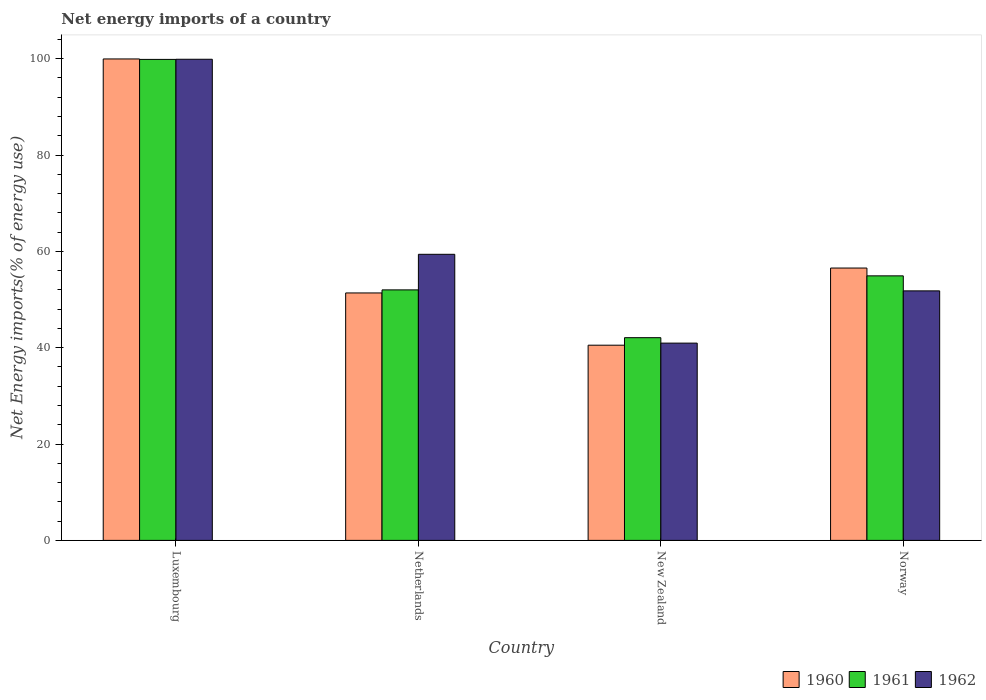Are the number of bars per tick equal to the number of legend labels?
Make the answer very short. Yes. Are the number of bars on each tick of the X-axis equal?
Ensure brevity in your answer.  Yes. How many bars are there on the 3rd tick from the right?
Offer a very short reply. 3. What is the label of the 3rd group of bars from the left?
Give a very brief answer. New Zealand. What is the net energy imports in 1960 in Luxembourg?
Your response must be concise. 99.95. Across all countries, what is the maximum net energy imports in 1962?
Offer a terse response. 99.88. Across all countries, what is the minimum net energy imports in 1962?
Offer a very short reply. 40.95. In which country was the net energy imports in 1961 maximum?
Keep it short and to the point. Luxembourg. In which country was the net energy imports in 1961 minimum?
Offer a terse response. New Zealand. What is the total net energy imports in 1962 in the graph?
Give a very brief answer. 252.03. What is the difference between the net energy imports in 1960 in Luxembourg and that in Norway?
Keep it short and to the point. 43.41. What is the difference between the net energy imports in 1962 in New Zealand and the net energy imports in 1960 in Netherlands?
Your answer should be very brief. -10.42. What is the average net energy imports in 1961 per country?
Your answer should be compact. 62.21. What is the difference between the net energy imports of/in 1961 and net energy imports of/in 1960 in Norway?
Offer a very short reply. -1.62. What is the ratio of the net energy imports in 1961 in Luxembourg to that in Norway?
Provide a short and direct response. 1.82. Is the difference between the net energy imports in 1961 in Netherlands and Norway greater than the difference between the net energy imports in 1960 in Netherlands and Norway?
Your answer should be compact. Yes. What is the difference between the highest and the second highest net energy imports in 1962?
Provide a succinct answer. -40.49. What is the difference between the highest and the lowest net energy imports in 1960?
Your response must be concise. 59.43. In how many countries, is the net energy imports in 1960 greater than the average net energy imports in 1960 taken over all countries?
Your answer should be very brief. 1. What does the 2nd bar from the left in Luxembourg represents?
Your response must be concise. 1961. Is it the case that in every country, the sum of the net energy imports in 1962 and net energy imports in 1961 is greater than the net energy imports in 1960?
Offer a terse response. Yes. How many bars are there?
Give a very brief answer. 12. How many countries are there in the graph?
Your answer should be very brief. 4. What is the difference between two consecutive major ticks on the Y-axis?
Ensure brevity in your answer.  20. Where does the legend appear in the graph?
Provide a succinct answer. Bottom right. How many legend labels are there?
Ensure brevity in your answer.  3. What is the title of the graph?
Give a very brief answer. Net energy imports of a country. What is the label or title of the X-axis?
Ensure brevity in your answer.  Country. What is the label or title of the Y-axis?
Provide a short and direct response. Net Energy imports(% of energy use). What is the Net Energy imports(% of energy use) in 1960 in Luxembourg?
Your response must be concise. 99.95. What is the Net Energy imports(% of energy use) in 1961 in Luxembourg?
Make the answer very short. 99.85. What is the Net Energy imports(% of energy use) of 1962 in Luxembourg?
Provide a short and direct response. 99.88. What is the Net Energy imports(% of energy use) of 1960 in Netherlands?
Make the answer very short. 51.37. What is the Net Energy imports(% of energy use) in 1961 in Netherlands?
Provide a short and direct response. 52. What is the Net Energy imports(% of energy use) of 1962 in Netherlands?
Provide a succinct answer. 59.39. What is the Net Energy imports(% of energy use) of 1960 in New Zealand?
Your response must be concise. 40.52. What is the Net Energy imports(% of energy use) in 1961 in New Zealand?
Offer a terse response. 42.08. What is the Net Energy imports(% of energy use) of 1962 in New Zealand?
Your answer should be very brief. 40.95. What is the Net Energy imports(% of energy use) of 1960 in Norway?
Your answer should be compact. 56.54. What is the Net Energy imports(% of energy use) in 1961 in Norway?
Ensure brevity in your answer.  54.92. What is the Net Energy imports(% of energy use) of 1962 in Norway?
Ensure brevity in your answer.  51.8. Across all countries, what is the maximum Net Energy imports(% of energy use) of 1960?
Offer a very short reply. 99.95. Across all countries, what is the maximum Net Energy imports(% of energy use) in 1961?
Offer a very short reply. 99.85. Across all countries, what is the maximum Net Energy imports(% of energy use) of 1962?
Your answer should be very brief. 99.88. Across all countries, what is the minimum Net Energy imports(% of energy use) in 1960?
Provide a short and direct response. 40.52. Across all countries, what is the minimum Net Energy imports(% of energy use) in 1961?
Keep it short and to the point. 42.08. Across all countries, what is the minimum Net Energy imports(% of energy use) in 1962?
Make the answer very short. 40.95. What is the total Net Energy imports(% of energy use) of 1960 in the graph?
Provide a short and direct response. 248.38. What is the total Net Energy imports(% of energy use) in 1961 in the graph?
Offer a very short reply. 248.86. What is the total Net Energy imports(% of energy use) in 1962 in the graph?
Ensure brevity in your answer.  252.03. What is the difference between the Net Energy imports(% of energy use) of 1960 in Luxembourg and that in Netherlands?
Your answer should be very brief. 48.58. What is the difference between the Net Energy imports(% of energy use) of 1961 in Luxembourg and that in Netherlands?
Ensure brevity in your answer.  47.85. What is the difference between the Net Energy imports(% of energy use) in 1962 in Luxembourg and that in Netherlands?
Provide a succinct answer. 40.49. What is the difference between the Net Energy imports(% of energy use) of 1960 in Luxembourg and that in New Zealand?
Make the answer very short. 59.43. What is the difference between the Net Energy imports(% of energy use) in 1961 in Luxembourg and that in New Zealand?
Make the answer very short. 57.77. What is the difference between the Net Energy imports(% of energy use) in 1962 in Luxembourg and that in New Zealand?
Your answer should be compact. 58.93. What is the difference between the Net Energy imports(% of energy use) of 1960 in Luxembourg and that in Norway?
Give a very brief answer. 43.41. What is the difference between the Net Energy imports(% of energy use) of 1961 in Luxembourg and that in Norway?
Ensure brevity in your answer.  44.94. What is the difference between the Net Energy imports(% of energy use) of 1962 in Luxembourg and that in Norway?
Make the answer very short. 48.08. What is the difference between the Net Energy imports(% of energy use) in 1960 in Netherlands and that in New Zealand?
Your answer should be compact. 10.85. What is the difference between the Net Energy imports(% of energy use) in 1961 in Netherlands and that in New Zealand?
Keep it short and to the point. 9.92. What is the difference between the Net Energy imports(% of energy use) in 1962 in Netherlands and that in New Zealand?
Your response must be concise. 18.44. What is the difference between the Net Energy imports(% of energy use) of 1960 in Netherlands and that in Norway?
Keep it short and to the point. -5.17. What is the difference between the Net Energy imports(% of energy use) of 1961 in Netherlands and that in Norway?
Your answer should be very brief. -2.91. What is the difference between the Net Energy imports(% of energy use) of 1962 in Netherlands and that in Norway?
Make the answer very short. 7.59. What is the difference between the Net Energy imports(% of energy use) of 1960 in New Zealand and that in Norway?
Your answer should be compact. -16.02. What is the difference between the Net Energy imports(% of energy use) of 1961 in New Zealand and that in Norway?
Your response must be concise. -12.83. What is the difference between the Net Energy imports(% of energy use) in 1962 in New Zealand and that in Norway?
Provide a short and direct response. -10.85. What is the difference between the Net Energy imports(% of energy use) in 1960 in Luxembourg and the Net Energy imports(% of energy use) in 1961 in Netherlands?
Your answer should be compact. 47.94. What is the difference between the Net Energy imports(% of energy use) of 1960 in Luxembourg and the Net Energy imports(% of energy use) of 1962 in Netherlands?
Keep it short and to the point. 40.56. What is the difference between the Net Energy imports(% of energy use) in 1961 in Luxembourg and the Net Energy imports(% of energy use) in 1962 in Netherlands?
Offer a very short reply. 40.46. What is the difference between the Net Energy imports(% of energy use) of 1960 in Luxembourg and the Net Energy imports(% of energy use) of 1961 in New Zealand?
Your response must be concise. 57.87. What is the difference between the Net Energy imports(% of energy use) in 1960 in Luxembourg and the Net Energy imports(% of energy use) in 1962 in New Zealand?
Offer a very short reply. 58.99. What is the difference between the Net Energy imports(% of energy use) of 1961 in Luxembourg and the Net Energy imports(% of energy use) of 1962 in New Zealand?
Your answer should be very brief. 58.9. What is the difference between the Net Energy imports(% of energy use) in 1960 in Luxembourg and the Net Energy imports(% of energy use) in 1961 in Norway?
Keep it short and to the point. 45.03. What is the difference between the Net Energy imports(% of energy use) in 1960 in Luxembourg and the Net Energy imports(% of energy use) in 1962 in Norway?
Offer a very short reply. 48.15. What is the difference between the Net Energy imports(% of energy use) in 1961 in Luxembourg and the Net Energy imports(% of energy use) in 1962 in Norway?
Provide a short and direct response. 48.05. What is the difference between the Net Energy imports(% of energy use) of 1960 in Netherlands and the Net Energy imports(% of energy use) of 1961 in New Zealand?
Your answer should be very brief. 9.29. What is the difference between the Net Energy imports(% of energy use) of 1960 in Netherlands and the Net Energy imports(% of energy use) of 1962 in New Zealand?
Provide a short and direct response. 10.42. What is the difference between the Net Energy imports(% of energy use) of 1961 in Netherlands and the Net Energy imports(% of energy use) of 1962 in New Zealand?
Make the answer very short. 11.05. What is the difference between the Net Energy imports(% of energy use) of 1960 in Netherlands and the Net Energy imports(% of energy use) of 1961 in Norway?
Make the answer very short. -3.55. What is the difference between the Net Energy imports(% of energy use) of 1960 in Netherlands and the Net Energy imports(% of energy use) of 1962 in Norway?
Offer a terse response. -0.43. What is the difference between the Net Energy imports(% of energy use) in 1961 in Netherlands and the Net Energy imports(% of energy use) in 1962 in Norway?
Offer a very short reply. 0.2. What is the difference between the Net Energy imports(% of energy use) in 1960 in New Zealand and the Net Energy imports(% of energy use) in 1961 in Norway?
Offer a very short reply. -14.39. What is the difference between the Net Energy imports(% of energy use) of 1960 in New Zealand and the Net Energy imports(% of energy use) of 1962 in Norway?
Give a very brief answer. -11.28. What is the difference between the Net Energy imports(% of energy use) in 1961 in New Zealand and the Net Energy imports(% of energy use) in 1962 in Norway?
Give a very brief answer. -9.72. What is the average Net Energy imports(% of energy use) of 1960 per country?
Provide a short and direct response. 62.09. What is the average Net Energy imports(% of energy use) in 1961 per country?
Give a very brief answer. 62.21. What is the average Net Energy imports(% of energy use) of 1962 per country?
Provide a succinct answer. 63.01. What is the difference between the Net Energy imports(% of energy use) in 1960 and Net Energy imports(% of energy use) in 1961 in Luxembourg?
Give a very brief answer. 0.09. What is the difference between the Net Energy imports(% of energy use) of 1960 and Net Energy imports(% of energy use) of 1962 in Luxembourg?
Your answer should be very brief. 0.06. What is the difference between the Net Energy imports(% of energy use) in 1961 and Net Energy imports(% of energy use) in 1962 in Luxembourg?
Keep it short and to the point. -0.03. What is the difference between the Net Energy imports(% of energy use) of 1960 and Net Energy imports(% of energy use) of 1961 in Netherlands?
Give a very brief answer. -0.64. What is the difference between the Net Energy imports(% of energy use) of 1960 and Net Energy imports(% of energy use) of 1962 in Netherlands?
Your answer should be very brief. -8.02. What is the difference between the Net Energy imports(% of energy use) of 1961 and Net Energy imports(% of energy use) of 1962 in Netherlands?
Your answer should be compact. -7.39. What is the difference between the Net Energy imports(% of energy use) in 1960 and Net Energy imports(% of energy use) in 1961 in New Zealand?
Make the answer very short. -1.56. What is the difference between the Net Energy imports(% of energy use) of 1960 and Net Energy imports(% of energy use) of 1962 in New Zealand?
Your response must be concise. -0.43. What is the difference between the Net Energy imports(% of energy use) in 1961 and Net Energy imports(% of energy use) in 1962 in New Zealand?
Offer a terse response. 1.13. What is the difference between the Net Energy imports(% of energy use) of 1960 and Net Energy imports(% of energy use) of 1961 in Norway?
Keep it short and to the point. 1.62. What is the difference between the Net Energy imports(% of energy use) in 1960 and Net Energy imports(% of energy use) in 1962 in Norway?
Ensure brevity in your answer.  4.74. What is the difference between the Net Energy imports(% of energy use) of 1961 and Net Energy imports(% of energy use) of 1962 in Norway?
Your answer should be very brief. 3.12. What is the ratio of the Net Energy imports(% of energy use) in 1960 in Luxembourg to that in Netherlands?
Offer a terse response. 1.95. What is the ratio of the Net Energy imports(% of energy use) in 1961 in Luxembourg to that in Netherlands?
Provide a short and direct response. 1.92. What is the ratio of the Net Energy imports(% of energy use) in 1962 in Luxembourg to that in Netherlands?
Provide a short and direct response. 1.68. What is the ratio of the Net Energy imports(% of energy use) in 1960 in Luxembourg to that in New Zealand?
Your answer should be very brief. 2.47. What is the ratio of the Net Energy imports(% of energy use) of 1961 in Luxembourg to that in New Zealand?
Provide a succinct answer. 2.37. What is the ratio of the Net Energy imports(% of energy use) of 1962 in Luxembourg to that in New Zealand?
Ensure brevity in your answer.  2.44. What is the ratio of the Net Energy imports(% of energy use) in 1960 in Luxembourg to that in Norway?
Provide a short and direct response. 1.77. What is the ratio of the Net Energy imports(% of energy use) of 1961 in Luxembourg to that in Norway?
Your answer should be compact. 1.82. What is the ratio of the Net Energy imports(% of energy use) of 1962 in Luxembourg to that in Norway?
Make the answer very short. 1.93. What is the ratio of the Net Energy imports(% of energy use) in 1960 in Netherlands to that in New Zealand?
Give a very brief answer. 1.27. What is the ratio of the Net Energy imports(% of energy use) of 1961 in Netherlands to that in New Zealand?
Keep it short and to the point. 1.24. What is the ratio of the Net Energy imports(% of energy use) of 1962 in Netherlands to that in New Zealand?
Provide a succinct answer. 1.45. What is the ratio of the Net Energy imports(% of energy use) in 1960 in Netherlands to that in Norway?
Offer a terse response. 0.91. What is the ratio of the Net Energy imports(% of energy use) in 1961 in Netherlands to that in Norway?
Offer a terse response. 0.95. What is the ratio of the Net Energy imports(% of energy use) of 1962 in Netherlands to that in Norway?
Provide a short and direct response. 1.15. What is the ratio of the Net Energy imports(% of energy use) in 1960 in New Zealand to that in Norway?
Make the answer very short. 0.72. What is the ratio of the Net Energy imports(% of energy use) in 1961 in New Zealand to that in Norway?
Keep it short and to the point. 0.77. What is the ratio of the Net Energy imports(% of energy use) of 1962 in New Zealand to that in Norway?
Your answer should be very brief. 0.79. What is the difference between the highest and the second highest Net Energy imports(% of energy use) in 1960?
Provide a short and direct response. 43.41. What is the difference between the highest and the second highest Net Energy imports(% of energy use) in 1961?
Your answer should be compact. 44.94. What is the difference between the highest and the second highest Net Energy imports(% of energy use) in 1962?
Give a very brief answer. 40.49. What is the difference between the highest and the lowest Net Energy imports(% of energy use) of 1960?
Provide a succinct answer. 59.43. What is the difference between the highest and the lowest Net Energy imports(% of energy use) in 1961?
Offer a very short reply. 57.77. What is the difference between the highest and the lowest Net Energy imports(% of energy use) of 1962?
Ensure brevity in your answer.  58.93. 